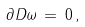<formula> <loc_0><loc_0><loc_500><loc_500>\partial D \omega \, = \, 0 \, ,</formula> 